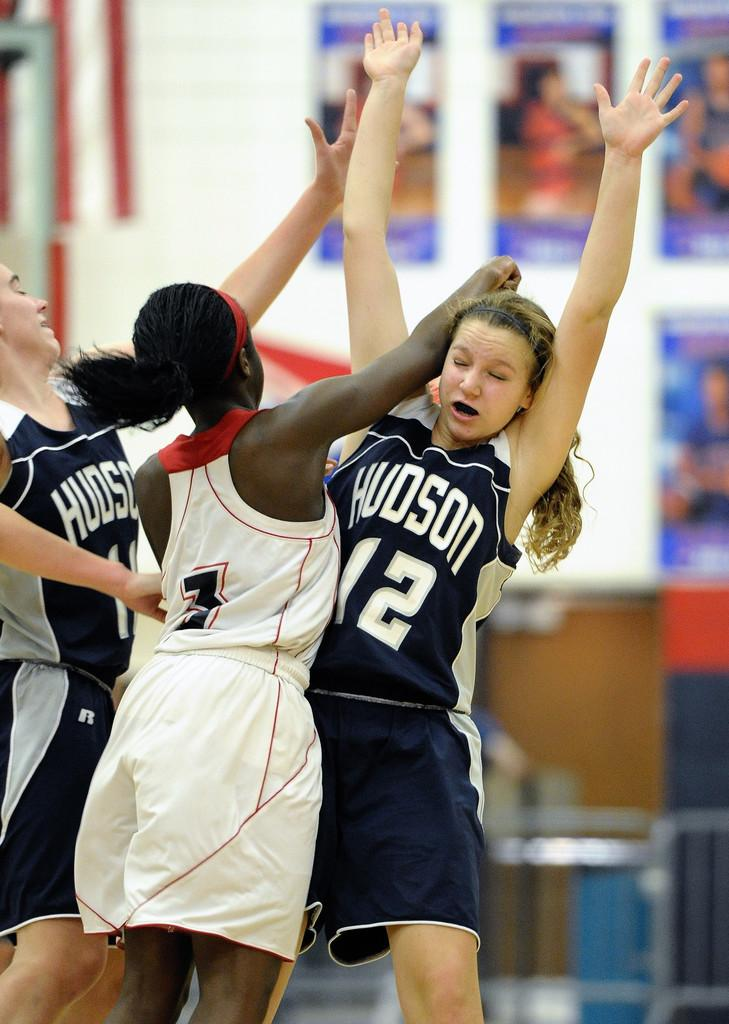How many people are in the image? There are three women in the image. What can be observed about the background in the image? The background has a blurred view. Are there any additional objects or features in the image? Yes, there are posters visible in the image. What type of jeans are the women wearing in the image? There is no information about the women's clothing in the image, so it cannot be determined if they are wearing jeans or any other type of clothing. What is the growth rate of the rabbit in the image? There is no rabbit present in the image, so it is impossible to determine its growth rate. 